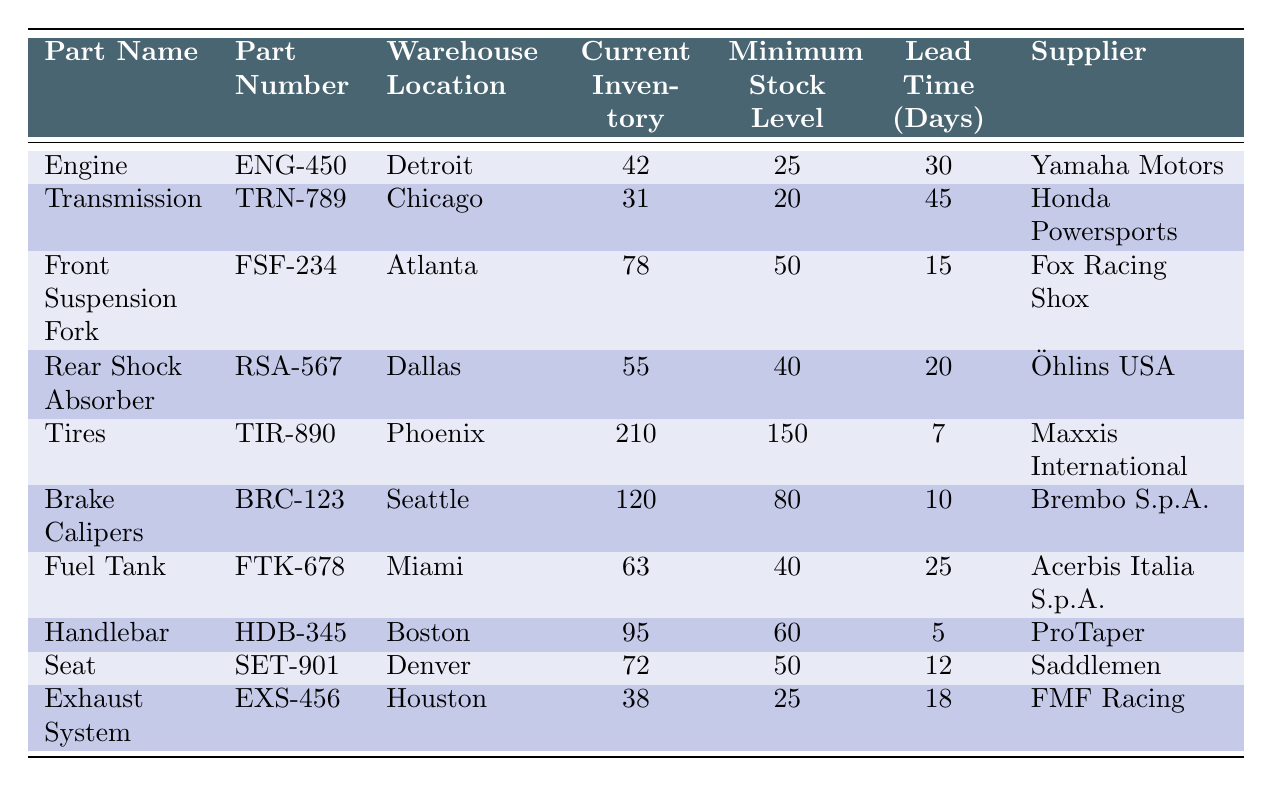What is the current inventory of the "Brake Calipers"? The table lists the "Brake Calipers" with a current inventory of 120 units in the Seattle warehouse.
Answer: 120 Which warehouse has the least amount of current inventory? By checking all the current inventory levels, "Transmission" in the Chicago warehouse has the least at 31 units.
Answer: Chicago Is the current inventory of the "Fuel Tank" above its minimum stock level? The current inventory of the "Fuel Tank" is 63 units, while its minimum stock level is 40 units. Since 63 is greater than 40, it is above the minimum.
Answer: Yes What is the lead time for the "Handlebar"? The lead time for the "Handlebar" in Boston is specified as 5 days in the table.
Answer: 5 days Add the current inventory of "Tires" and "Front Suspension Fork". What is the total? The current inventory of "Tires" is 210 and "Front Suspension Fork" is 78. To find the total, we add these values: 210 + 78 = 288.
Answer: 288 Are "Engine" and "Exhaust System" supplied by the same company? The "Engine" is supplied by "Yamaha Motors" and the "Exhaust System" by "FMF Racing". These are different suppliers, indicating they are not supplied by the same company.
Answer: No What is the difference in current inventory between "Rear Shock Absorber" and "Exhaust System"? The "Rear Shock Absorber" has 55 units, while the "Exhaust System" has 38 units. The difference is calculated as 55 - 38 = 17 units.
Answer: 17 Which part has the highest current inventory? By reviewing the inventory levels, the "Tires" hold the highest current inventory at 210 units.
Answer: Tires What are the minimum stock levels for the parts supplied by "Acerbis Italia S.p.A."? The part supplied by "Acerbis Italia S.p.A." is the "Fuel Tank", which has a minimum stock level of 40 units as per the table.
Answer: 40 If we categorize "Brake Calipers" and "Tires" as critical parts, what is their average current inventory? The current inventory for "Brake Calipers" is 120 and for "Tires" is 210. To find the average, we add: 120 + 210 = 330, then divide by 2 (the number of parts) which is 330/2 = 165.
Answer: 165 